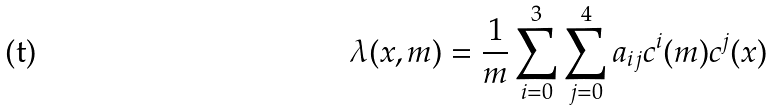<formula> <loc_0><loc_0><loc_500><loc_500>\lambda ( x , m ) = \frac { 1 } { m } \sum _ { i = 0 } ^ { 3 } \sum _ { j = 0 } ^ { 4 } a _ { i j } c ^ { i } ( m ) c ^ { j } ( x )</formula> 